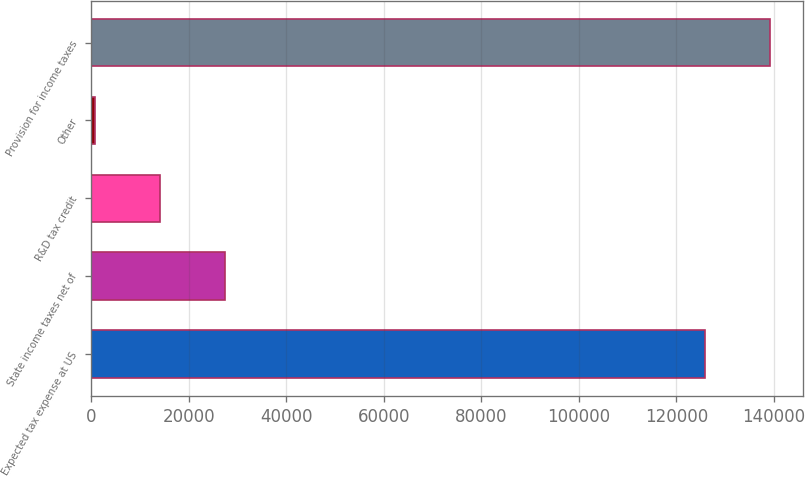Convert chart to OTSL. <chart><loc_0><loc_0><loc_500><loc_500><bar_chart><fcel>Expected tax expense at US<fcel>State income taxes net of<fcel>R&D tax credit<fcel>Other<fcel>Provision for income taxes<nl><fcel>125833<fcel>27388<fcel>14137<fcel>886<fcel>139084<nl></chart> 